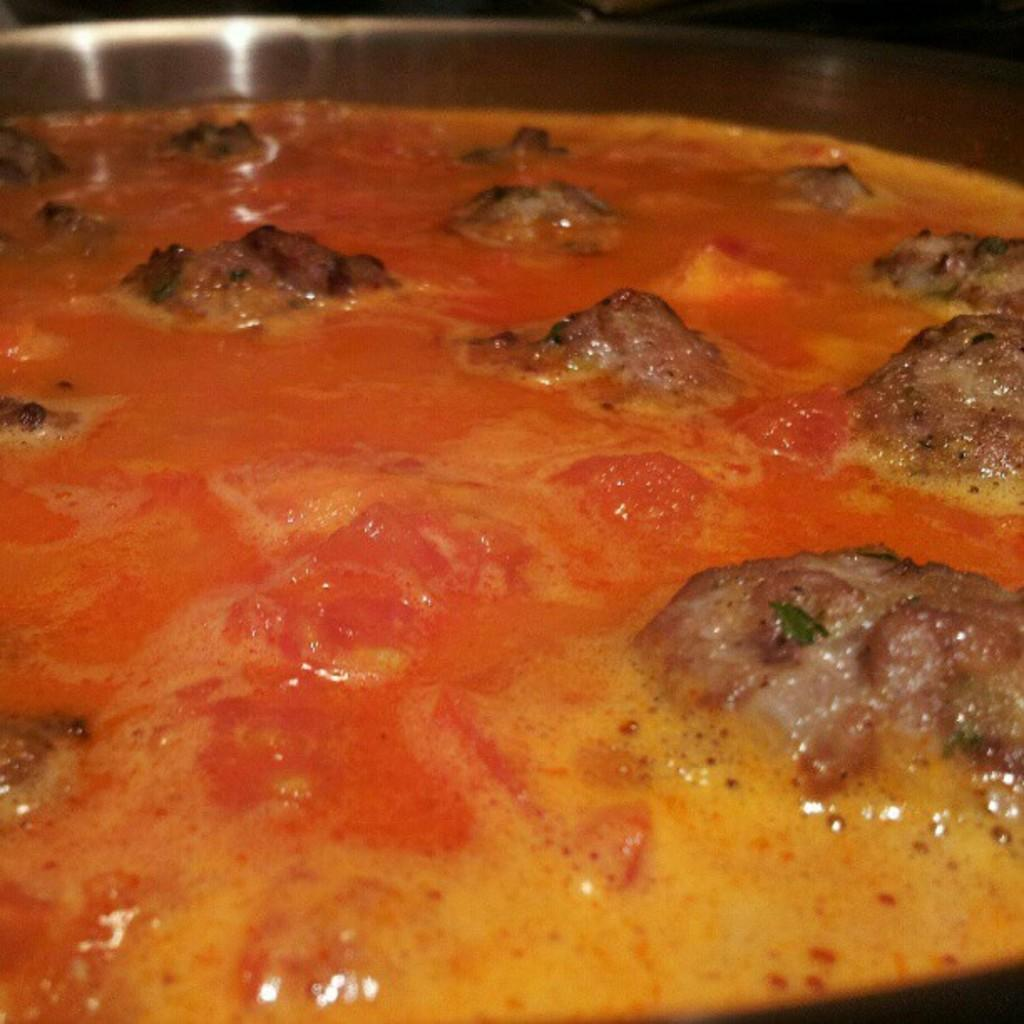What colors are present in the food in the image? The food in the image has yellow, brown, and red colors. What is the color of the bowl containing the food? The food is in a brown color bowl. What color is the background of the image? The background of the image is black. How many beds can be seen in the image? There are no beds present in the image. What type of experience can be gained from the food in the image? The image does not convey any specific experience related to the food; it only shows the colors and arrangement of the food in a bowl. 